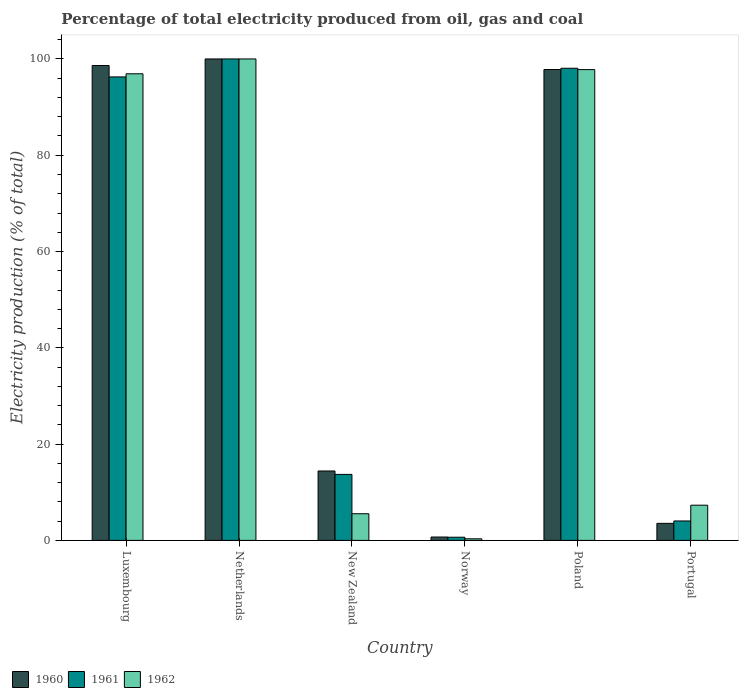How many groups of bars are there?
Provide a short and direct response. 6. Are the number of bars per tick equal to the number of legend labels?
Provide a succinct answer. Yes. Are the number of bars on each tick of the X-axis equal?
Give a very brief answer. Yes. How many bars are there on the 4th tick from the right?
Offer a very short reply. 3. What is the label of the 2nd group of bars from the left?
Your answer should be compact. Netherlands. In how many cases, is the number of bars for a given country not equal to the number of legend labels?
Make the answer very short. 0. What is the electricity production in in 1962 in Portugal?
Give a very brief answer. 7.31. Across all countries, what is the minimum electricity production in in 1961?
Offer a very short reply. 0.66. What is the total electricity production in in 1962 in the graph?
Offer a very short reply. 307.88. What is the difference between the electricity production in in 1960 in Norway and that in Poland?
Keep it short and to the point. -97.1. What is the difference between the electricity production in in 1962 in Luxembourg and the electricity production in in 1960 in Netherlands?
Provide a succinct answer. -3.08. What is the average electricity production in in 1960 per country?
Provide a succinct answer. 52.51. What is the difference between the electricity production in of/in 1960 and electricity production in of/in 1962 in Poland?
Ensure brevity in your answer.  0.01. What is the ratio of the electricity production in in 1961 in Netherlands to that in Norway?
Offer a very short reply. 152.21. What is the difference between the highest and the second highest electricity production in in 1962?
Your answer should be compact. -0.87. What is the difference between the highest and the lowest electricity production in in 1962?
Keep it short and to the point. 99.67. Is the sum of the electricity production in in 1960 in Netherlands and Poland greater than the maximum electricity production in in 1961 across all countries?
Your answer should be very brief. Yes. What does the 1st bar from the left in Poland represents?
Ensure brevity in your answer.  1960. Is it the case that in every country, the sum of the electricity production in in 1961 and electricity production in in 1962 is greater than the electricity production in in 1960?
Keep it short and to the point. Yes. How many bars are there?
Offer a terse response. 18. Are all the bars in the graph horizontal?
Your response must be concise. No. How many countries are there in the graph?
Offer a very short reply. 6. Are the values on the major ticks of Y-axis written in scientific E-notation?
Offer a terse response. No. Does the graph contain grids?
Make the answer very short. No. Where does the legend appear in the graph?
Make the answer very short. Bottom left. How are the legend labels stacked?
Provide a short and direct response. Horizontal. What is the title of the graph?
Offer a terse response. Percentage of total electricity produced from oil, gas and coal. Does "1994" appear as one of the legend labels in the graph?
Give a very brief answer. No. What is the label or title of the X-axis?
Provide a succinct answer. Country. What is the label or title of the Y-axis?
Offer a terse response. Electricity production (% of total). What is the Electricity production (% of total) in 1960 in Luxembourg?
Ensure brevity in your answer.  98.63. What is the Electricity production (% of total) of 1961 in Luxembourg?
Ensure brevity in your answer.  96.27. What is the Electricity production (% of total) in 1962 in Luxembourg?
Your answer should be compact. 96.92. What is the Electricity production (% of total) in 1960 in New Zealand?
Offer a very short reply. 14.42. What is the Electricity production (% of total) in 1961 in New Zealand?
Make the answer very short. 13.71. What is the Electricity production (% of total) of 1962 in New Zealand?
Offer a terse response. 5.54. What is the Electricity production (% of total) of 1960 in Norway?
Your response must be concise. 0.7. What is the Electricity production (% of total) of 1961 in Norway?
Make the answer very short. 0.66. What is the Electricity production (% of total) of 1962 in Norway?
Your answer should be very brief. 0.33. What is the Electricity production (% of total) in 1960 in Poland?
Your answer should be compact. 97.8. What is the Electricity production (% of total) of 1961 in Poland?
Give a very brief answer. 98.07. What is the Electricity production (% of total) in 1962 in Poland?
Offer a terse response. 97.79. What is the Electricity production (% of total) in 1960 in Portugal?
Your answer should be very brief. 3.54. What is the Electricity production (% of total) in 1961 in Portugal?
Offer a very short reply. 4.04. What is the Electricity production (% of total) of 1962 in Portugal?
Make the answer very short. 7.31. Across all countries, what is the maximum Electricity production (% of total) of 1962?
Your answer should be very brief. 100. Across all countries, what is the minimum Electricity production (% of total) of 1960?
Ensure brevity in your answer.  0.7. Across all countries, what is the minimum Electricity production (% of total) of 1961?
Your answer should be very brief. 0.66. Across all countries, what is the minimum Electricity production (% of total) of 1962?
Your response must be concise. 0.33. What is the total Electricity production (% of total) of 1960 in the graph?
Your answer should be compact. 315.09. What is the total Electricity production (% of total) in 1961 in the graph?
Make the answer very short. 312.74. What is the total Electricity production (% of total) of 1962 in the graph?
Provide a succinct answer. 307.88. What is the difference between the Electricity production (% of total) of 1960 in Luxembourg and that in Netherlands?
Offer a very short reply. -1.37. What is the difference between the Electricity production (% of total) of 1961 in Luxembourg and that in Netherlands?
Provide a succinct answer. -3.73. What is the difference between the Electricity production (% of total) in 1962 in Luxembourg and that in Netherlands?
Ensure brevity in your answer.  -3.08. What is the difference between the Electricity production (% of total) in 1960 in Luxembourg and that in New Zealand?
Provide a short and direct response. 84.22. What is the difference between the Electricity production (% of total) of 1961 in Luxembourg and that in New Zealand?
Give a very brief answer. 82.56. What is the difference between the Electricity production (% of total) in 1962 in Luxembourg and that in New Zealand?
Make the answer very short. 91.38. What is the difference between the Electricity production (% of total) in 1960 in Luxembourg and that in Norway?
Your response must be concise. 97.93. What is the difference between the Electricity production (% of total) of 1961 in Luxembourg and that in Norway?
Make the answer very short. 95.61. What is the difference between the Electricity production (% of total) in 1962 in Luxembourg and that in Norway?
Provide a succinct answer. 96.59. What is the difference between the Electricity production (% of total) in 1960 in Luxembourg and that in Poland?
Your answer should be compact. 0.83. What is the difference between the Electricity production (% of total) of 1961 in Luxembourg and that in Poland?
Your answer should be very brief. -1.8. What is the difference between the Electricity production (% of total) in 1962 in Luxembourg and that in Poland?
Offer a very short reply. -0.87. What is the difference between the Electricity production (% of total) in 1960 in Luxembourg and that in Portugal?
Offer a terse response. 95.1. What is the difference between the Electricity production (% of total) of 1961 in Luxembourg and that in Portugal?
Make the answer very short. 92.23. What is the difference between the Electricity production (% of total) of 1962 in Luxembourg and that in Portugal?
Offer a terse response. 89.61. What is the difference between the Electricity production (% of total) in 1960 in Netherlands and that in New Zealand?
Make the answer very short. 85.58. What is the difference between the Electricity production (% of total) in 1961 in Netherlands and that in New Zealand?
Your answer should be very brief. 86.29. What is the difference between the Electricity production (% of total) of 1962 in Netherlands and that in New Zealand?
Your answer should be very brief. 94.46. What is the difference between the Electricity production (% of total) in 1960 in Netherlands and that in Norway?
Provide a succinct answer. 99.3. What is the difference between the Electricity production (% of total) in 1961 in Netherlands and that in Norway?
Offer a very short reply. 99.34. What is the difference between the Electricity production (% of total) of 1962 in Netherlands and that in Norway?
Give a very brief answer. 99.67. What is the difference between the Electricity production (% of total) in 1960 in Netherlands and that in Poland?
Make the answer very short. 2.2. What is the difference between the Electricity production (% of total) in 1961 in Netherlands and that in Poland?
Offer a terse response. 1.93. What is the difference between the Electricity production (% of total) in 1962 in Netherlands and that in Poland?
Provide a succinct answer. 2.21. What is the difference between the Electricity production (% of total) in 1960 in Netherlands and that in Portugal?
Offer a terse response. 96.46. What is the difference between the Electricity production (% of total) of 1961 in Netherlands and that in Portugal?
Keep it short and to the point. 95.96. What is the difference between the Electricity production (% of total) in 1962 in Netherlands and that in Portugal?
Give a very brief answer. 92.69. What is the difference between the Electricity production (% of total) of 1960 in New Zealand and that in Norway?
Offer a terse response. 13.72. What is the difference between the Electricity production (% of total) of 1961 in New Zealand and that in Norway?
Provide a short and direct response. 13.05. What is the difference between the Electricity production (% of total) of 1962 in New Zealand and that in Norway?
Keep it short and to the point. 5.21. What is the difference between the Electricity production (% of total) in 1960 in New Zealand and that in Poland?
Make the answer very short. -83.38. What is the difference between the Electricity production (% of total) of 1961 in New Zealand and that in Poland?
Offer a terse response. -84.36. What is the difference between the Electricity production (% of total) of 1962 in New Zealand and that in Poland?
Provide a succinct answer. -92.25. What is the difference between the Electricity production (% of total) of 1960 in New Zealand and that in Portugal?
Give a very brief answer. 10.88. What is the difference between the Electricity production (% of total) of 1961 in New Zealand and that in Portugal?
Give a very brief answer. 9.67. What is the difference between the Electricity production (% of total) in 1962 in New Zealand and that in Portugal?
Keep it short and to the point. -1.77. What is the difference between the Electricity production (% of total) in 1960 in Norway and that in Poland?
Give a very brief answer. -97.1. What is the difference between the Electricity production (% of total) of 1961 in Norway and that in Poland?
Your answer should be compact. -97.41. What is the difference between the Electricity production (% of total) in 1962 in Norway and that in Poland?
Offer a very short reply. -97.46. What is the difference between the Electricity production (% of total) of 1960 in Norway and that in Portugal?
Your answer should be very brief. -2.84. What is the difference between the Electricity production (% of total) in 1961 in Norway and that in Portugal?
Offer a very short reply. -3.38. What is the difference between the Electricity production (% of total) in 1962 in Norway and that in Portugal?
Your answer should be compact. -6.98. What is the difference between the Electricity production (% of total) in 1960 in Poland and that in Portugal?
Your response must be concise. 94.26. What is the difference between the Electricity production (% of total) in 1961 in Poland and that in Portugal?
Ensure brevity in your answer.  94.03. What is the difference between the Electricity production (% of total) in 1962 in Poland and that in Portugal?
Your response must be concise. 90.48. What is the difference between the Electricity production (% of total) of 1960 in Luxembourg and the Electricity production (% of total) of 1961 in Netherlands?
Offer a very short reply. -1.37. What is the difference between the Electricity production (% of total) of 1960 in Luxembourg and the Electricity production (% of total) of 1962 in Netherlands?
Your answer should be very brief. -1.37. What is the difference between the Electricity production (% of total) in 1961 in Luxembourg and the Electricity production (% of total) in 1962 in Netherlands?
Keep it short and to the point. -3.73. What is the difference between the Electricity production (% of total) in 1960 in Luxembourg and the Electricity production (% of total) in 1961 in New Zealand?
Your answer should be compact. 84.93. What is the difference between the Electricity production (% of total) in 1960 in Luxembourg and the Electricity production (% of total) in 1962 in New Zealand?
Provide a succinct answer. 93.1. What is the difference between the Electricity production (% of total) of 1961 in Luxembourg and the Electricity production (% of total) of 1962 in New Zealand?
Keep it short and to the point. 90.73. What is the difference between the Electricity production (% of total) in 1960 in Luxembourg and the Electricity production (% of total) in 1961 in Norway?
Your answer should be compact. 97.98. What is the difference between the Electricity production (% of total) in 1960 in Luxembourg and the Electricity production (% of total) in 1962 in Norway?
Keep it short and to the point. 98.3. What is the difference between the Electricity production (% of total) of 1961 in Luxembourg and the Electricity production (% of total) of 1962 in Norway?
Give a very brief answer. 95.94. What is the difference between the Electricity production (% of total) of 1960 in Luxembourg and the Electricity production (% of total) of 1961 in Poland?
Provide a succinct answer. 0.57. What is the difference between the Electricity production (% of total) in 1960 in Luxembourg and the Electricity production (% of total) in 1962 in Poland?
Your response must be concise. 0.85. What is the difference between the Electricity production (% of total) in 1961 in Luxembourg and the Electricity production (% of total) in 1962 in Poland?
Provide a succinct answer. -1.52. What is the difference between the Electricity production (% of total) of 1960 in Luxembourg and the Electricity production (% of total) of 1961 in Portugal?
Provide a short and direct response. 94.6. What is the difference between the Electricity production (% of total) in 1960 in Luxembourg and the Electricity production (% of total) in 1962 in Portugal?
Ensure brevity in your answer.  91.33. What is the difference between the Electricity production (% of total) in 1961 in Luxembourg and the Electricity production (% of total) in 1962 in Portugal?
Your answer should be very brief. 88.96. What is the difference between the Electricity production (% of total) of 1960 in Netherlands and the Electricity production (% of total) of 1961 in New Zealand?
Make the answer very short. 86.29. What is the difference between the Electricity production (% of total) of 1960 in Netherlands and the Electricity production (% of total) of 1962 in New Zealand?
Offer a terse response. 94.46. What is the difference between the Electricity production (% of total) in 1961 in Netherlands and the Electricity production (% of total) in 1962 in New Zealand?
Ensure brevity in your answer.  94.46. What is the difference between the Electricity production (% of total) of 1960 in Netherlands and the Electricity production (% of total) of 1961 in Norway?
Provide a short and direct response. 99.34. What is the difference between the Electricity production (% of total) of 1960 in Netherlands and the Electricity production (% of total) of 1962 in Norway?
Make the answer very short. 99.67. What is the difference between the Electricity production (% of total) in 1961 in Netherlands and the Electricity production (% of total) in 1962 in Norway?
Give a very brief answer. 99.67. What is the difference between the Electricity production (% of total) in 1960 in Netherlands and the Electricity production (% of total) in 1961 in Poland?
Offer a terse response. 1.93. What is the difference between the Electricity production (% of total) of 1960 in Netherlands and the Electricity production (% of total) of 1962 in Poland?
Your answer should be very brief. 2.21. What is the difference between the Electricity production (% of total) of 1961 in Netherlands and the Electricity production (% of total) of 1962 in Poland?
Provide a short and direct response. 2.21. What is the difference between the Electricity production (% of total) in 1960 in Netherlands and the Electricity production (% of total) in 1961 in Portugal?
Make the answer very short. 95.96. What is the difference between the Electricity production (% of total) of 1960 in Netherlands and the Electricity production (% of total) of 1962 in Portugal?
Your answer should be very brief. 92.69. What is the difference between the Electricity production (% of total) of 1961 in Netherlands and the Electricity production (% of total) of 1962 in Portugal?
Offer a very short reply. 92.69. What is the difference between the Electricity production (% of total) of 1960 in New Zealand and the Electricity production (% of total) of 1961 in Norway?
Provide a short and direct response. 13.76. What is the difference between the Electricity production (% of total) in 1960 in New Zealand and the Electricity production (% of total) in 1962 in Norway?
Give a very brief answer. 14.09. What is the difference between the Electricity production (% of total) in 1961 in New Zealand and the Electricity production (% of total) in 1962 in Norway?
Your answer should be compact. 13.38. What is the difference between the Electricity production (% of total) in 1960 in New Zealand and the Electricity production (% of total) in 1961 in Poland?
Provide a succinct answer. -83.65. What is the difference between the Electricity production (% of total) of 1960 in New Zealand and the Electricity production (% of total) of 1962 in Poland?
Your answer should be compact. -83.37. What is the difference between the Electricity production (% of total) in 1961 in New Zealand and the Electricity production (% of total) in 1962 in Poland?
Ensure brevity in your answer.  -84.08. What is the difference between the Electricity production (% of total) of 1960 in New Zealand and the Electricity production (% of total) of 1961 in Portugal?
Your answer should be compact. 10.38. What is the difference between the Electricity production (% of total) of 1960 in New Zealand and the Electricity production (% of total) of 1962 in Portugal?
Keep it short and to the point. 7.11. What is the difference between the Electricity production (% of total) in 1961 in New Zealand and the Electricity production (% of total) in 1962 in Portugal?
Ensure brevity in your answer.  6.4. What is the difference between the Electricity production (% of total) of 1960 in Norway and the Electricity production (% of total) of 1961 in Poland?
Provide a succinct answer. -97.37. What is the difference between the Electricity production (% of total) of 1960 in Norway and the Electricity production (% of total) of 1962 in Poland?
Give a very brief answer. -97.09. What is the difference between the Electricity production (% of total) in 1961 in Norway and the Electricity production (% of total) in 1962 in Poland?
Provide a short and direct response. -97.13. What is the difference between the Electricity production (% of total) of 1960 in Norway and the Electricity production (% of total) of 1961 in Portugal?
Offer a terse response. -3.34. What is the difference between the Electricity production (% of total) of 1960 in Norway and the Electricity production (% of total) of 1962 in Portugal?
Your answer should be very brief. -6.61. What is the difference between the Electricity production (% of total) in 1961 in Norway and the Electricity production (% of total) in 1962 in Portugal?
Your response must be concise. -6.65. What is the difference between the Electricity production (% of total) in 1960 in Poland and the Electricity production (% of total) in 1961 in Portugal?
Ensure brevity in your answer.  93.76. What is the difference between the Electricity production (% of total) of 1960 in Poland and the Electricity production (% of total) of 1962 in Portugal?
Ensure brevity in your answer.  90.49. What is the difference between the Electricity production (% of total) in 1961 in Poland and the Electricity production (% of total) in 1962 in Portugal?
Provide a succinct answer. 90.76. What is the average Electricity production (% of total) in 1960 per country?
Give a very brief answer. 52.51. What is the average Electricity production (% of total) in 1961 per country?
Provide a short and direct response. 52.12. What is the average Electricity production (% of total) in 1962 per country?
Ensure brevity in your answer.  51.31. What is the difference between the Electricity production (% of total) of 1960 and Electricity production (% of total) of 1961 in Luxembourg?
Keep it short and to the point. 2.36. What is the difference between the Electricity production (% of total) of 1960 and Electricity production (% of total) of 1962 in Luxembourg?
Provide a succinct answer. 1.72. What is the difference between the Electricity production (% of total) of 1961 and Electricity production (% of total) of 1962 in Luxembourg?
Offer a terse response. -0.65. What is the difference between the Electricity production (% of total) in 1960 and Electricity production (% of total) in 1961 in New Zealand?
Ensure brevity in your answer.  0.71. What is the difference between the Electricity production (% of total) of 1960 and Electricity production (% of total) of 1962 in New Zealand?
Provide a short and direct response. 8.88. What is the difference between the Electricity production (% of total) of 1961 and Electricity production (% of total) of 1962 in New Zealand?
Your answer should be very brief. 8.17. What is the difference between the Electricity production (% of total) of 1960 and Electricity production (% of total) of 1961 in Norway?
Offer a very short reply. 0.04. What is the difference between the Electricity production (% of total) of 1960 and Electricity production (% of total) of 1962 in Norway?
Make the answer very short. 0.37. What is the difference between the Electricity production (% of total) of 1961 and Electricity production (% of total) of 1962 in Norway?
Provide a succinct answer. 0.33. What is the difference between the Electricity production (% of total) in 1960 and Electricity production (% of total) in 1961 in Poland?
Ensure brevity in your answer.  -0.27. What is the difference between the Electricity production (% of total) in 1960 and Electricity production (% of total) in 1962 in Poland?
Offer a very short reply. 0.01. What is the difference between the Electricity production (% of total) in 1961 and Electricity production (% of total) in 1962 in Poland?
Offer a terse response. 0.28. What is the difference between the Electricity production (% of total) of 1960 and Electricity production (% of total) of 1961 in Portugal?
Make the answer very short. -0.5. What is the difference between the Electricity production (% of total) in 1960 and Electricity production (% of total) in 1962 in Portugal?
Your answer should be compact. -3.77. What is the difference between the Electricity production (% of total) of 1961 and Electricity production (% of total) of 1962 in Portugal?
Make the answer very short. -3.27. What is the ratio of the Electricity production (% of total) of 1960 in Luxembourg to that in Netherlands?
Offer a very short reply. 0.99. What is the ratio of the Electricity production (% of total) of 1961 in Luxembourg to that in Netherlands?
Provide a short and direct response. 0.96. What is the ratio of the Electricity production (% of total) of 1962 in Luxembourg to that in Netherlands?
Offer a terse response. 0.97. What is the ratio of the Electricity production (% of total) in 1960 in Luxembourg to that in New Zealand?
Your response must be concise. 6.84. What is the ratio of the Electricity production (% of total) in 1961 in Luxembourg to that in New Zealand?
Provide a succinct answer. 7.02. What is the ratio of the Electricity production (% of total) in 1962 in Luxembourg to that in New Zealand?
Your answer should be compact. 17.51. What is the ratio of the Electricity production (% of total) of 1960 in Luxembourg to that in Norway?
Your response must be concise. 140.97. What is the ratio of the Electricity production (% of total) in 1961 in Luxembourg to that in Norway?
Your answer should be very brief. 146.53. What is the ratio of the Electricity production (% of total) of 1962 in Luxembourg to that in Norway?
Offer a very short reply. 293.27. What is the ratio of the Electricity production (% of total) of 1960 in Luxembourg to that in Poland?
Make the answer very short. 1.01. What is the ratio of the Electricity production (% of total) of 1961 in Luxembourg to that in Poland?
Keep it short and to the point. 0.98. What is the ratio of the Electricity production (% of total) in 1962 in Luxembourg to that in Poland?
Your answer should be compact. 0.99. What is the ratio of the Electricity production (% of total) of 1960 in Luxembourg to that in Portugal?
Your answer should be compact. 27.88. What is the ratio of the Electricity production (% of total) in 1961 in Luxembourg to that in Portugal?
Your answer should be compact. 23.85. What is the ratio of the Electricity production (% of total) of 1962 in Luxembourg to that in Portugal?
Your answer should be compact. 13.26. What is the ratio of the Electricity production (% of total) of 1960 in Netherlands to that in New Zealand?
Your response must be concise. 6.94. What is the ratio of the Electricity production (% of total) of 1961 in Netherlands to that in New Zealand?
Make the answer very short. 7.29. What is the ratio of the Electricity production (% of total) in 1962 in Netherlands to that in New Zealand?
Give a very brief answer. 18.06. What is the ratio of the Electricity production (% of total) of 1960 in Netherlands to that in Norway?
Make the answer very short. 142.93. What is the ratio of the Electricity production (% of total) in 1961 in Netherlands to that in Norway?
Your answer should be very brief. 152.21. What is the ratio of the Electricity production (% of total) in 1962 in Netherlands to that in Norway?
Your answer should be very brief. 302.6. What is the ratio of the Electricity production (% of total) of 1960 in Netherlands to that in Poland?
Keep it short and to the point. 1.02. What is the ratio of the Electricity production (% of total) of 1961 in Netherlands to that in Poland?
Your answer should be compact. 1.02. What is the ratio of the Electricity production (% of total) of 1962 in Netherlands to that in Poland?
Provide a short and direct response. 1.02. What is the ratio of the Electricity production (% of total) in 1960 in Netherlands to that in Portugal?
Provide a short and direct response. 28.27. What is the ratio of the Electricity production (% of total) of 1961 in Netherlands to that in Portugal?
Make the answer very short. 24.78. What is the ratio of the Electricity production (% of total) of 1962 in Netherlands to that in Portugal?
Your answer should be very brief. 13.68. What is the ratio of the Electricity production (% of total) in 1960 in New Zealand to that in Norway?
Make the answer very short. 20.61. What is the ratio of the Electricity production (% of total) in 1961 in New Zealand to that in Norway?
Your answer should be compact. 20.87. What is the ratio of the Electricity production (% of total) in 1962 in New Zealand to that in Norway?
Your answer should be very brief. 16.75. What is the ratio of the Electricity production (% of total) in 1960 in New Zealand to that in Poland?
Your answer should be compact. 0.15. What is the ratio of the Electricity production (% of total) in 1961 in New Zealand to that in Poland?
Make the answer very short. 0.14. What is the ratio of the Electricity production (% of total) in 1962 in New Zealand to that in Poland?
Provide a succinct answer. 0.06. What is the ratio of the Electricity production (% of total) in 1960 in New Zealand to that in Portugal?
Offer a terse response. 4.08. What is the ratio of the Electricity production (% of total) in 1961 in New Zealand to that in Portugal?
Ensure brevity in your answer.  3.4. What is the ratio of the Electricity production (% of total) of 1962 in New Zealand to that in Portugal?
Offer a terse response. 0.76. What is the ratio of the Electricity production (% of total) in 1960 in Norway to that in Poland?
Your response must be concise. 0.01. What is the ratio of the Electricity production (% of total) of 1961 in Norway to that in Poland?
Make the answer very short. 0.01. What is the ratio of the Electricity production (% of total) of 1962 in Norway to that in Poland?
Your response must be concise. 0. What is the ratio of the Electricity production (% of total) in 1960 in Norway to that in Portugal?
Ensure brevity in your answer.  0.2. What is the ratio of the Electricity production (% of total) of 1961 in Norway to that in Portugal?
Offer a terse response. 0.16. What is the ratio of the Electricity production (% of total) in 1962 in Norway to that in Portugal?
Provide a succinct answer. 0.05. What is the ratio of the Electricity production (% of total) of 1960 in Poland to that in Portugal?
Ensure brevity in your answer.  27.65. What is the ratio of the Electricity production (% of total) in 1961 in Poland to that in Portugal?
Your response must be concise. 24.3. What is the ratio of the Electricity production (% of total) in 1962 in Poland to that in Portugal?
Keep it short and to the point. 13.38. What is the difference between the highest and the second highest Electricity production (% of total) of 1960?
Ensure brevity in your answer.  1.37. What is the difference between the highest and the second highest Electricity production (% of total) of 1961?
Offer a very short reply. 1.93. What is the difference between the highest and the second highest Electricity production (% of total) of 1962?
Your answer should be very brief. 2.21. What is the difference between the highest and the lowest Electricity production (% of total) in 1960?
Provide a short and direct response. 99.3. What is the difference between the highest and the lowest Electricity production (% of total) of 1961?
Give a very brief answer. 99.34. What is the difference between the highest and the lowest Electricity production (% of total) of 1962?
Your answer should be compact. 99.67. 